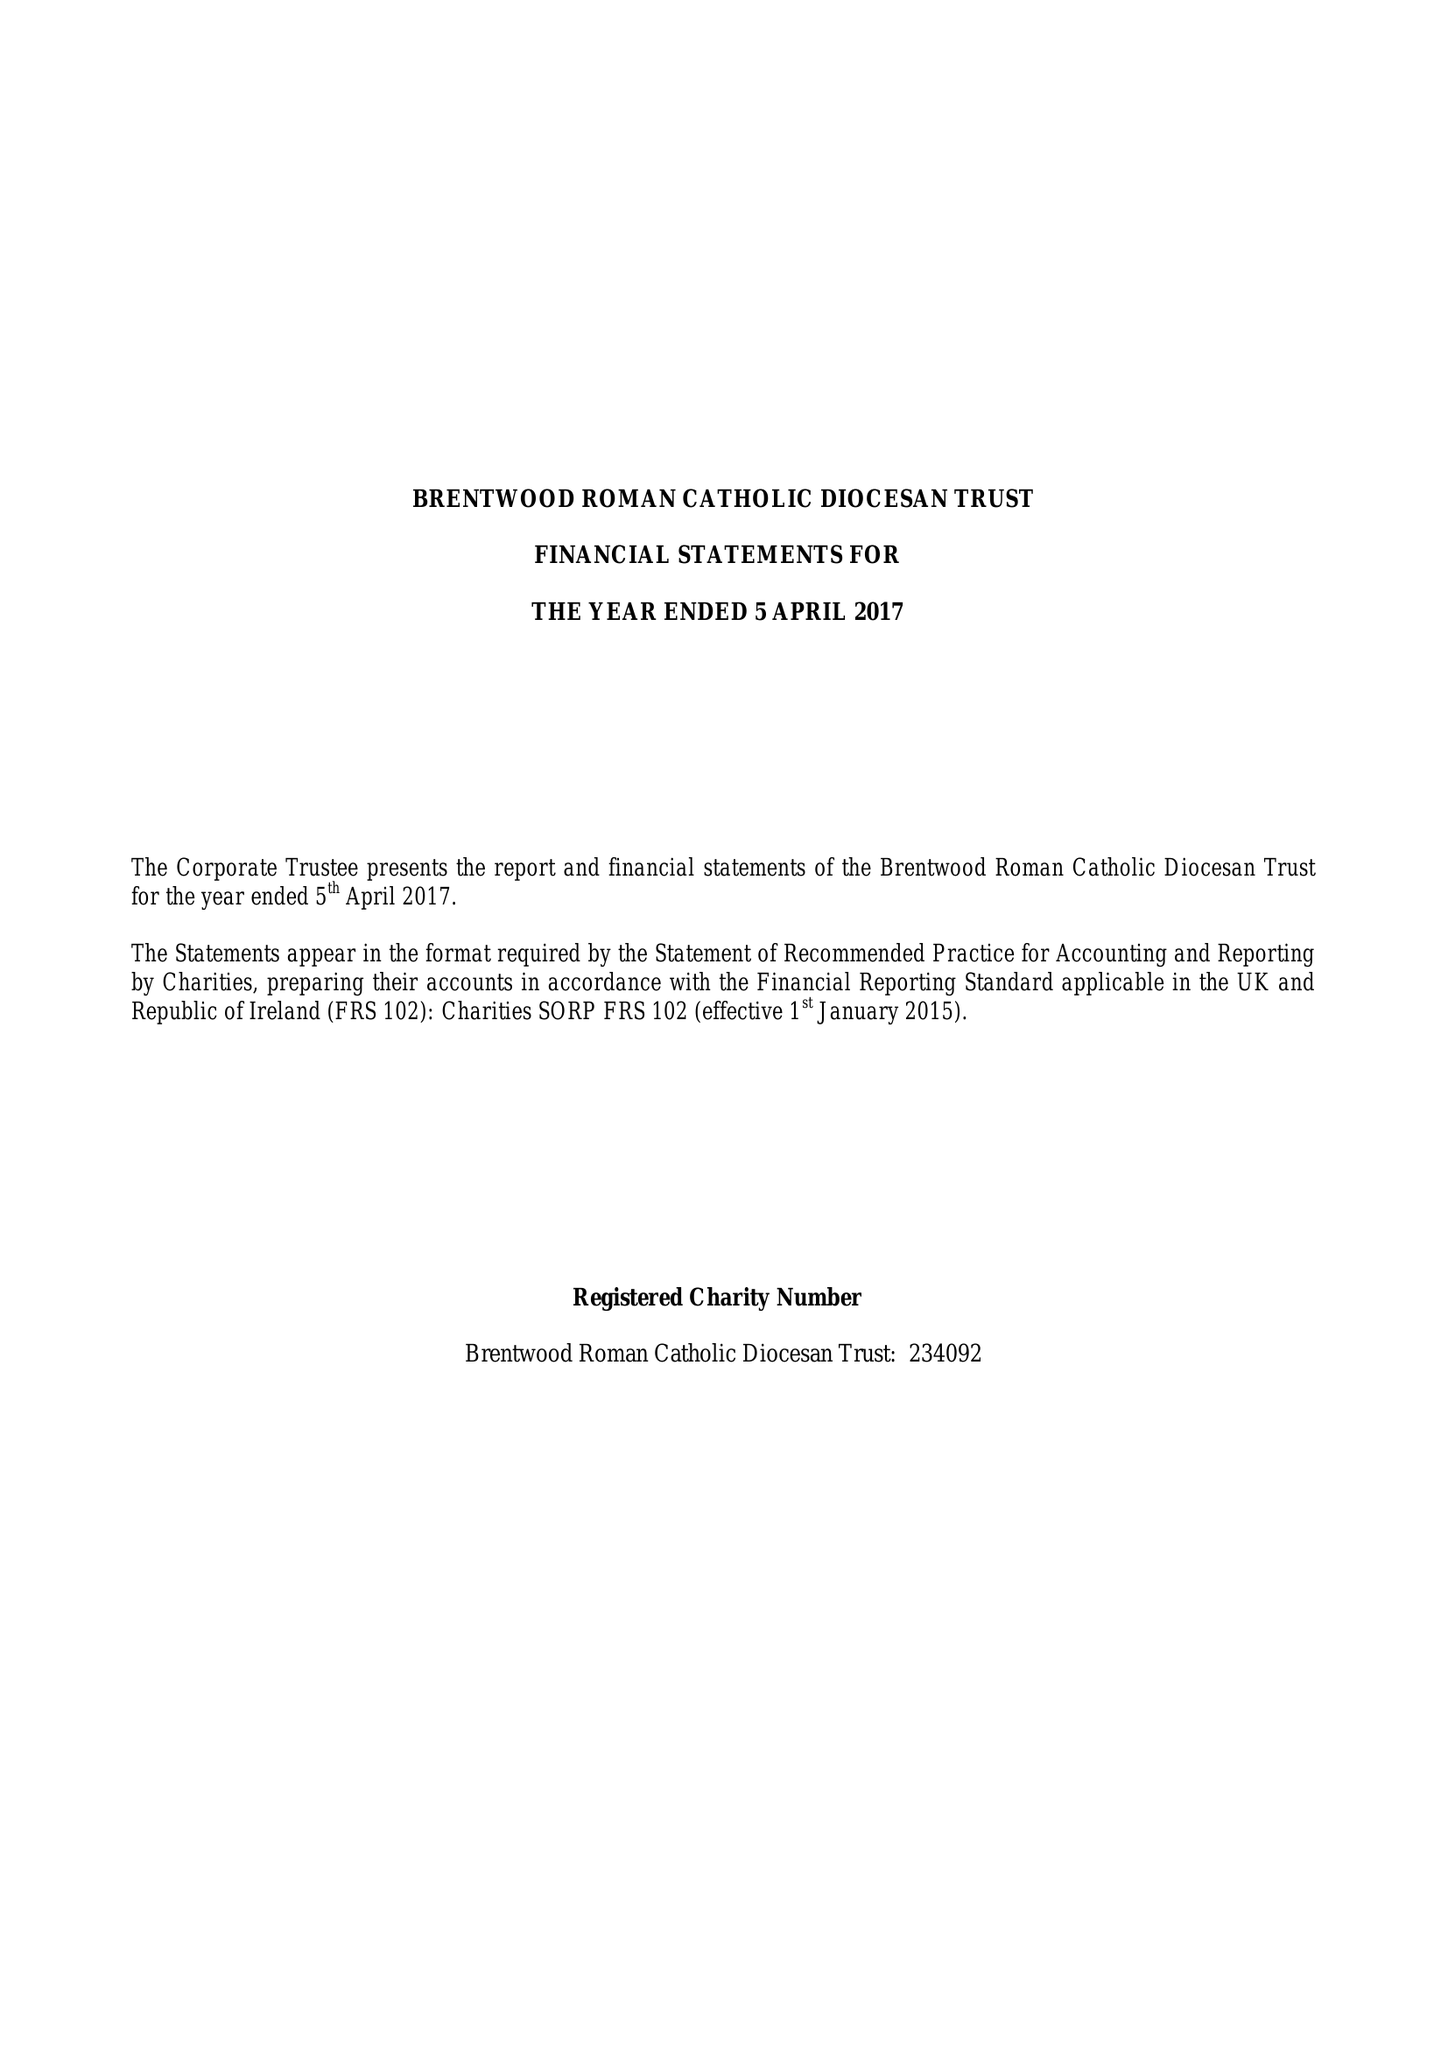What is the value for the charity_name?
Answer the question using a single word or phrase. Brentwood Roman Catholic Diocesan Trust 